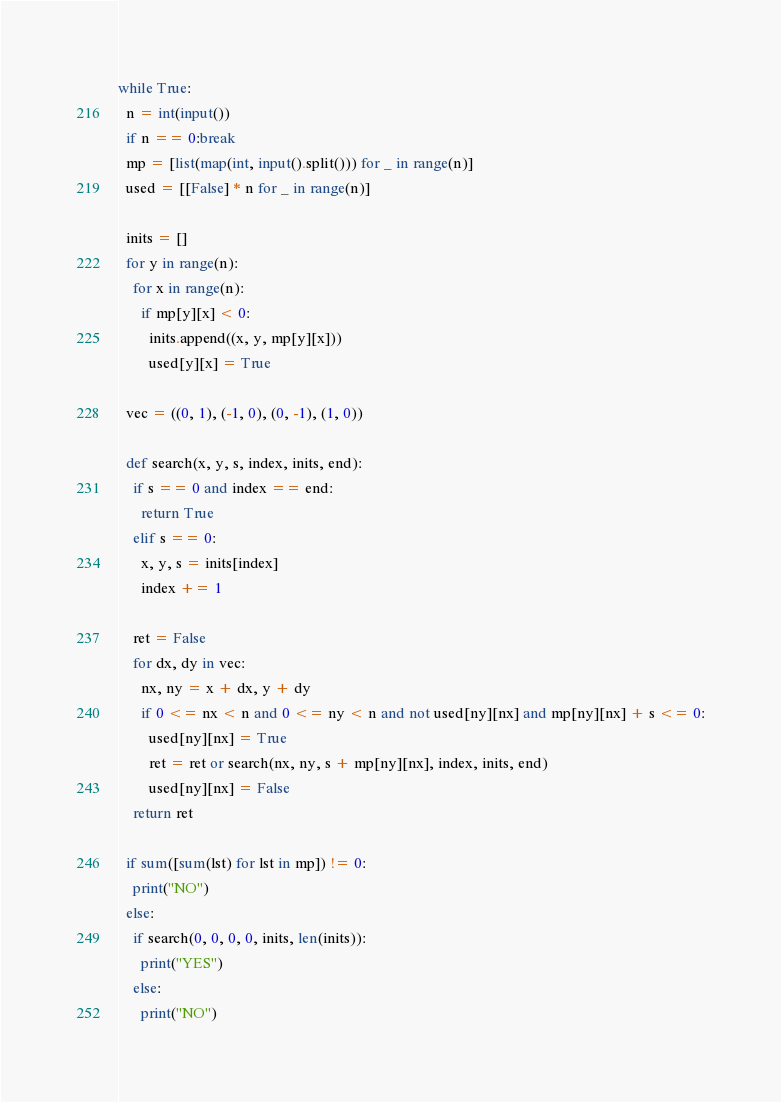Convert code to text. <code><loc_0><loc_0><loc_500><loc_500><_Python_>while True:
  n = int(input())
  if n == 0:break
  mp = [list(map(int, input().split())) for _ in range(n)]
  used = [[False] * n for _ in range(n)]
  
  inits = []
  for y in range(n):
    for x in range(n):
      if mp[y][x] < 0:
        inits.append((x, y, mp[y][x]))
        used[y][x] = True
  
  vec = ((0, 1), (-1, 0), (0, -1), (1, 0))
  
  def search(x, y, s, index, inits, end):
    if s == 0 and index == end:
      return True
    elif s == 0:
      x, y, s = inits[index]
      index += 1
    
    ret = False
    for dx, dy in vec:
      nx, ny = x + dx, y + dy
      if 0 <= nx < n and 0 <= ny < n and not used[ny][nx] and mp[ny][nx] + s <= 0:
        used[ny][nx] = True
        ret = ret or search(nx, ny, s + mp[ny][nx], index, inits, end)
        used[ny][nx] = False
    return ret
  
  if sum([sum(lst) for lst in mp]) != 0:
    print("NO")
  else:
    if search(0, 0, 0, 0, inits, len(inits)):
      print("YES")
    else:
      print("NO")
</code> 